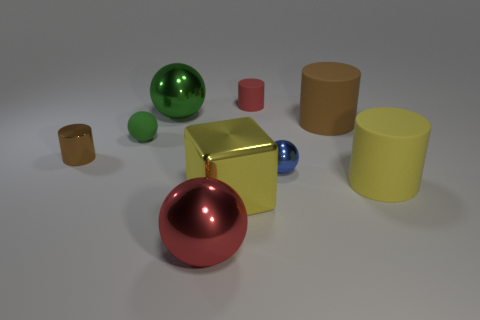Add 1 large green metallic spheres. How many objects exist? 10 Subtract all cylinders. How many objects are left? 5 Add 7 tiny rubber objects. How many tiny rubber objects exist? 9 Subtract 0 blue blocks. How many objects are left? 9 Subtract all green balls. Subtract all large metallic balls. How many objects are left? 5 Add 2 blocks. How many blocks are left? 3 